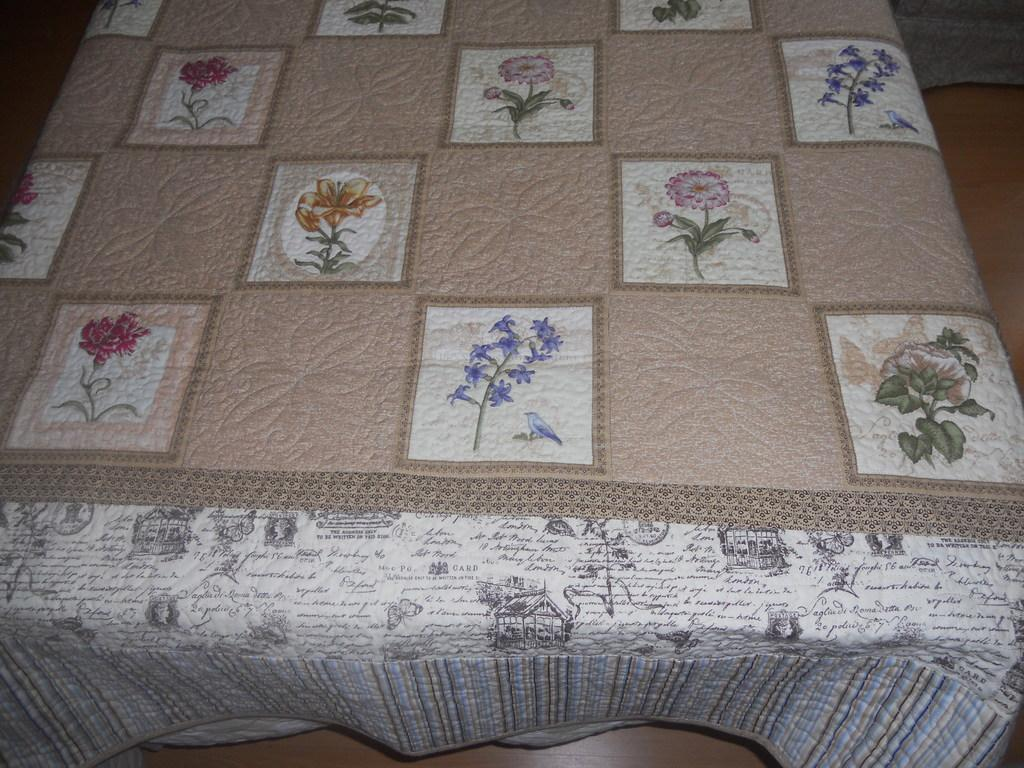What is the main object in the image? There is a cloth in the image. Can you describe the design on the cloth? The cloth has flower designs. Where is the cloth located in the image? The cloth is placed on a table. What type of trousers are being worn by the flowers on the cloth? There are no trousers or people present in the image; it only features a cloth with flower designs. 